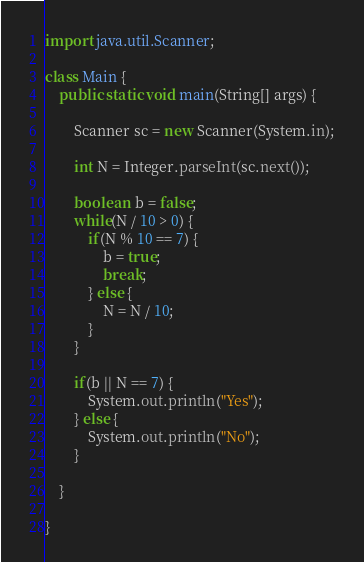<code> <loc_0><loc_0><loc_500><loc_500><_Java_>import java.util.Scanner;

class Main {
	public static void main(String[] args) {

		Scanner sc = new Scanner(System.in);

		int N = Integer.parseInt(sc.next());

		boolean  b = false;
		while(N / 10 > 0) {
			if(N % 10 == 7) {
				b = true;
				break;
			} else {
				N = N / 10;
			}
		}

		if(b || N == 7) {
			System.out.println("Yes");
		} else {
			System.out.println("No");
		}

	}

}
</code> 